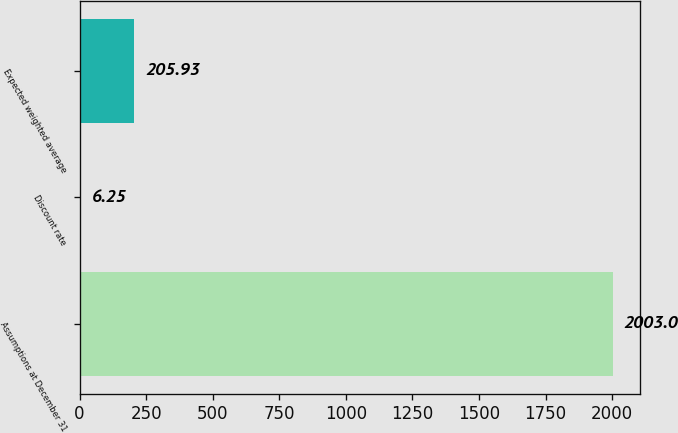<chart> <loc_0><loc_0><loc_500><loc_500><bar_chart><fcel>Assumptions at December 31<fcel>Discount rate<fcel>Expected weighted average<nl><fcel>2003<fcel>6.25<fcel>205.93<nl></chart> 